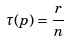Convert formula to latex. <formula><loc_0><loc_0><loc_500><loc_500>\tau ( p ) = \frac { r } { n }</formula> 